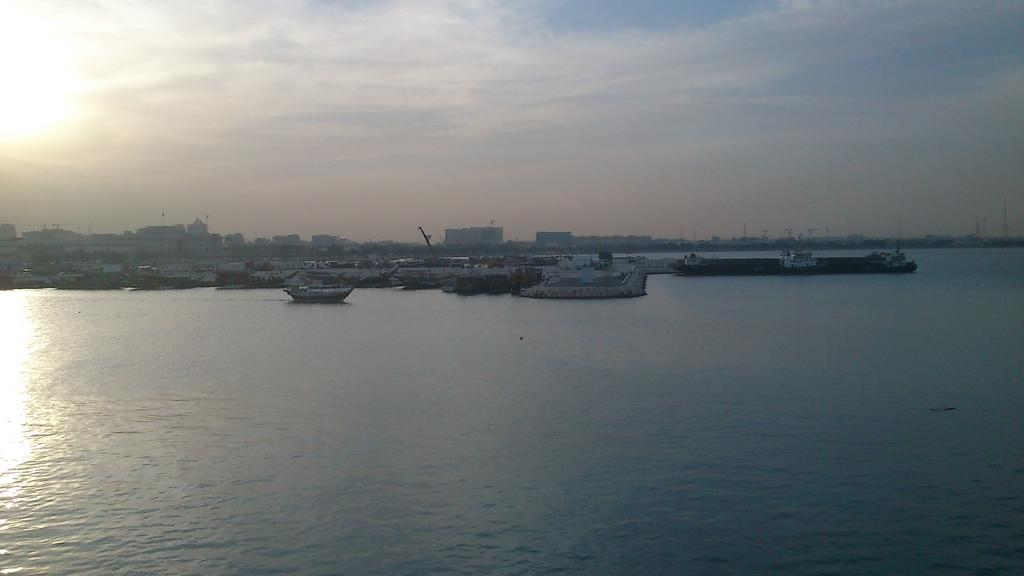What is in the foreground of the image? A: There is a water surface in the foreground of the image. What types of watercraft are on the water surface? There are ships and boats on the water surface. What can be seen in the background of the image? There are buildings, poles, and the sky visible in the background of the image. What position do the trains hold in the image? There are no trains present in the image. What type of trip can be seen taking place in the image? The image does not depict a trip; it shows a water surface with ships and boats, buildings, poles, and the sky in the background. 